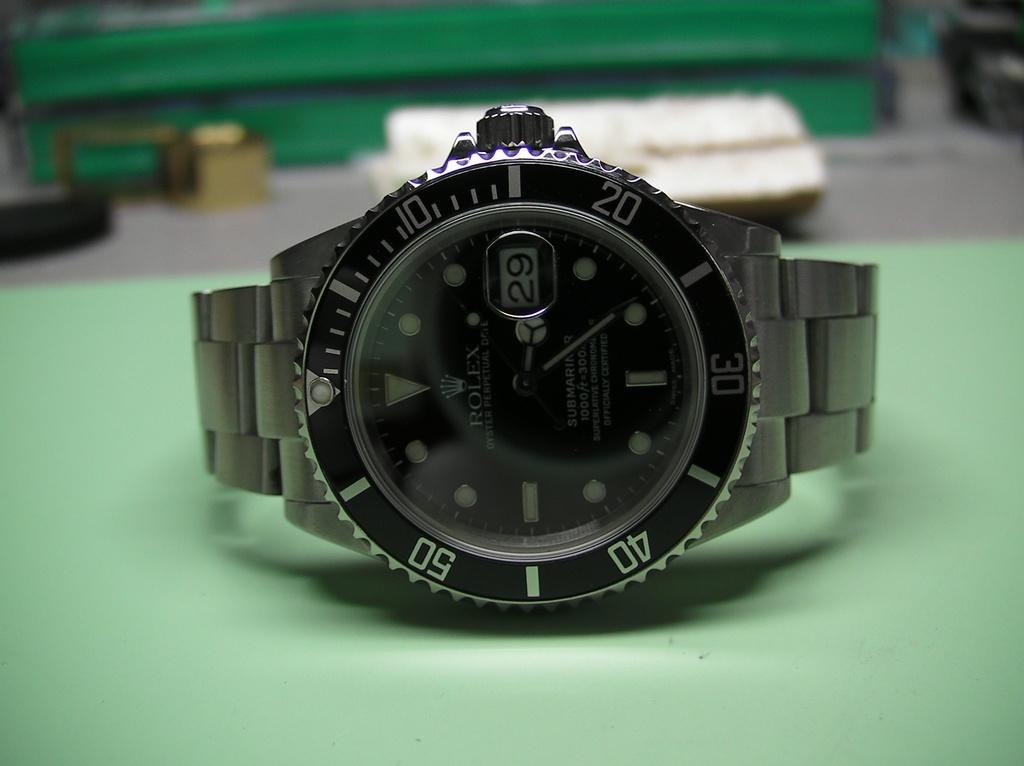<image>
Describe the image concisely. A rolex watch on a green table laying on it's side on the 29th. 